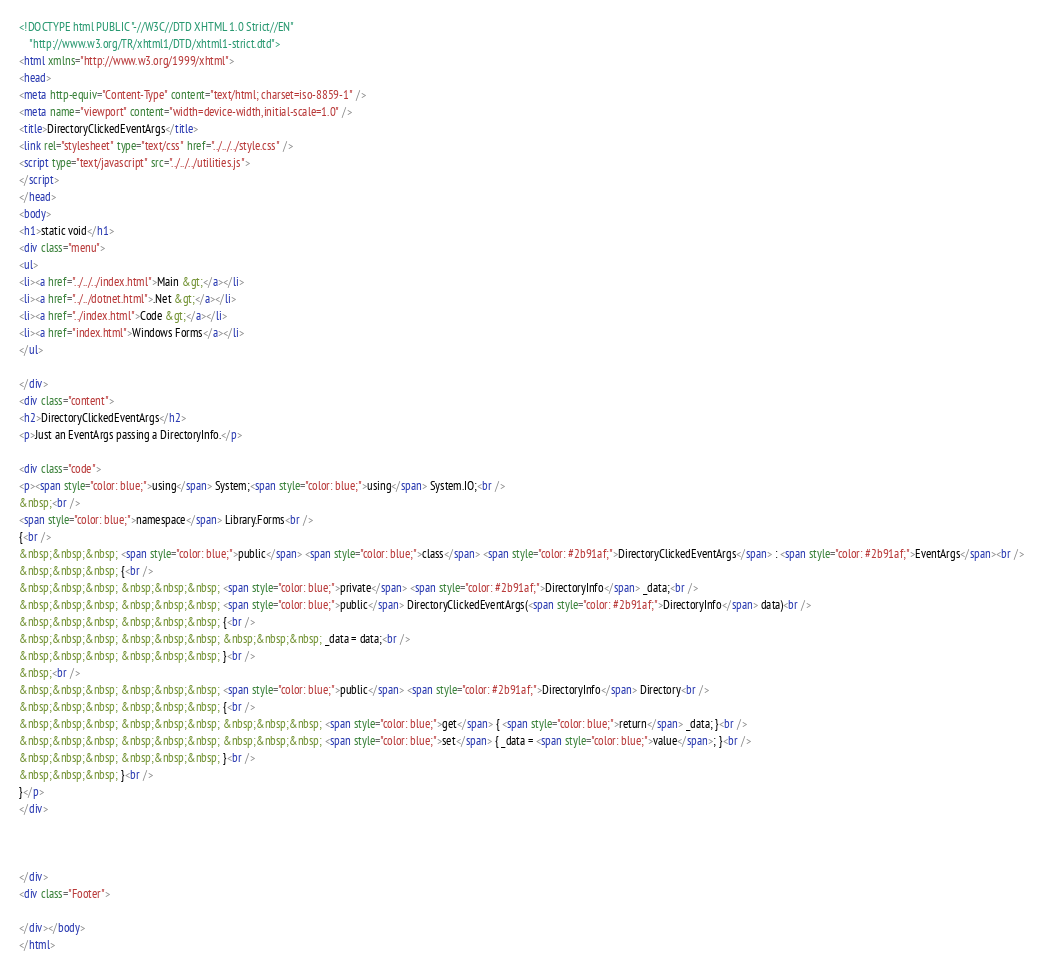Convert code to text. <code><loc_0><loc_0><loc_500><loc_500><_HTML_><!DOCTYPE html PUBLIC "-//W3C//DTD XHTML 1.0 Strict//EN"
    "http://www.w3.org/TR/xhtml1/DTD/xhtml1-strict.dtd">
<html xmlns="http://www.w3.org/1999/xhtml">
<head>
<meta http-equiv="Content-Type" content="text/html; charset=iso-8859-1" />
<meta name="viewport" content="width=device-width,initial-scale=1.0" />
<title>DirectoryClickedEventArgs</title>
<link rel="stylesheet" type="text/css" href="../../../style.css" />
<script type="text/javascript" src="../../../utilities.js">
</script>
</head>
<body>
<h1>static void</h1>
<div class="menu">
<ul>
<li><a href="../../../index.html">Main &gt;</a></li>
<li><a href="../../dotnet.html">.Net &gt;</a></li>
<li><a href="../index.html">Code &gt;</a></li>
<li><a href="index.html">Windows Forms</a></li>
</ul>

</div>
<div class="content">
<h2>DirectoryClickedEventArgs</h2>
<p>Just an EventArgs passing a DirectoryInfo.</p>

<div class="code">
<p><span style="color: blue;">using</span> System;<span style="color: blue;">using</span> System.IO;<br />
&nbsp;<br />
<span style="color: blue;">namespace</span> Library.Forms<br />
{<br />
&nbsp;&nbsp;&nbsp; <span style="color: blue;">public</span> <span style="color: blue;">class</span> <span style="color: #2b91af;">DirectoryClickedEventArgs</span> : <span style="color: #2b91af;">EventArgs</span><br />
&nbsp;&nbsp;&nbsp; {<br />
&nbsp;&nbsp;&nbsp; &nbsp;&nbsp;&nbsp; <span style="color: blue;">private</span> <span style="color: #2b91af;">DirectoryInfo</span> _data;<br />
&nbsp;&nbsp;&nbsp; &nbsp;&nbsp;&nbsp; <span style="color: blue;">public</span> DirectoryClickedEventArgs(<span style="color: #2b91af;">DirectoryInfo</span> data)<br />
&nbsp;&nbsp;&nbsp; &nbsp;&nbsp;&nbsp; {<br />
&nbsp;&nbsp;&nbsp; &nbsp;&nbsp;&nbsp; &nbsp;&nbsp;&nbsp; _data = data;<br />
&nbsp;&nbsp;&nbsp; &nbsp;&nbsp;&nbsp; }<br />
&nbsp;<br />
&nbsp;&nbsp;&nbsp; &nbsp;&nbsp;&nbsp; <span style="color: blue;">public</span> <span style="color: #2b91af;">DirectoryInfo</span> Directory<br />
&nbsp;&nbsp;&nbsp; &nbsp;&nbsp;&nbsp; {<br />
&nbsp;&nbsp;&nbsp; &nbsp;&nbsp;&nbsp; &nbsp;&nbsp;&nbsp; <span style="color: blue;">get</span> { <span style="color: blue;">return</span> _data; }<br />
&nbsp;&nbsp;&nbsp; &nbsp;&nbsp;&nbsp; &nbsp;&nbsp;&nbsp; <span style="color: blue;">set</span> { _data = <span style="color: blue;">value</span>; }<br />
&nbsp;&nbsp;&nbsp; &nbsp;&nbsp;&nbsp; }<br />
&nbsp;&nbsp;&nbsp; }<br />
}</p>
</div>



</div>
<div class="Footer">

</div></body>
</html>
</code> 